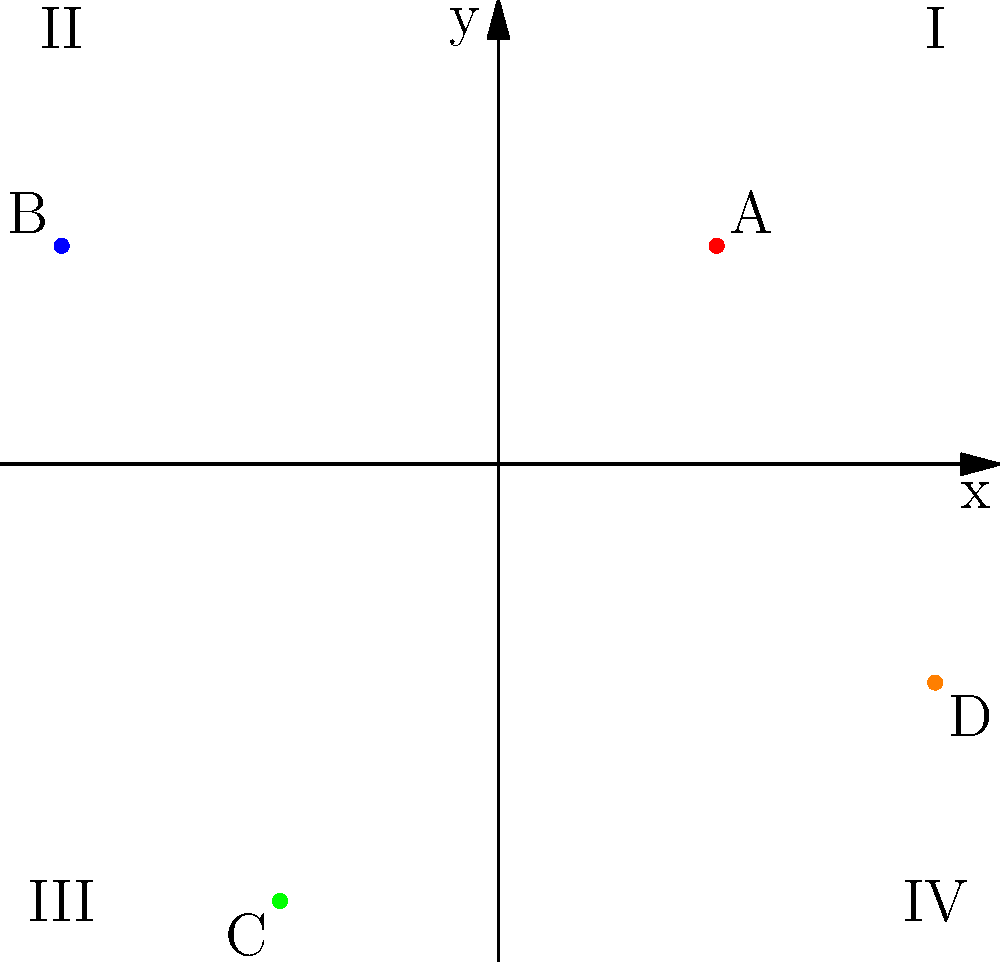In dental practice, we often use a coordinate system to precisely locate teeth in a patient's mouth. The origin (0,0) represents the center of the mouth, with the x-axis representing the horizontal plane and the y-axis representing the vertical plane. Positive x values indicate the right side, negative x values the left side, positive y values the upper jaw, and negative y values the lower jaw.

Given this information and the diagram above, which quadrant would a tooth located at position C be in, and what general area of the mouth does this represent? To determine the quadrant and area of the mouth for tooth C, let's follow these steps:

1. Recall the quadrant system:
   - Quadrant I: Positive x, Positive y (upper right)
   - Quadrant II: Negative x, Positive y (upper left)
   - Quadrant III: Negative x, Negative y (lower left)
   - Quadrant IV: Positive x, Negative y (lower right)

2. Locate point C on the coordinate plane:
   - C is at position (-1, -2)
   - The x-coordinate is negative (-1)
   - The y-coordinate is negative (-2)

3. Determine the quadrant:
   - Since both x and y are negative, point C is in Quadrant III

4. Interpret the location in the mouth:
   - Negative x indicates the left side of the mouth
   - Negative y indicates the lower jaw

5. Conclusion:
   - Tooth C is located in Quadrant III, which represents the lower left area of the mouth

This system allows for precise communication about tooth locations, which is crucial for accurate diagnoses and treatment plans in dental practice.
Answer: Quadrant III (lower left) 